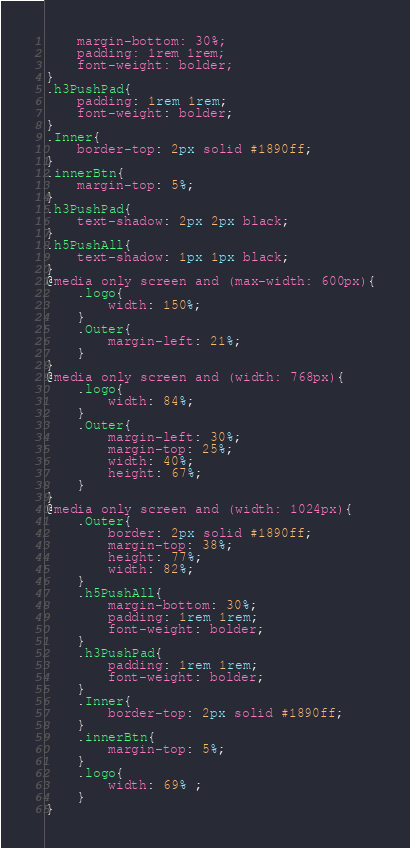Convert code to text. <code><loc_0><loc_0><loc_500><loc_500><_CSS_>    margin-bottom: 30%;
    padding: 1rem 1rem;
    font-weight: bolder;
}
.h3PushPad{
    padding: 1rem 1rem;
    font-weight: bolder;
}
.Inner{
    border-top: 2px solid #1890ff;
}
.innerBtn{
    margin-top: 5%;
}
.h3PushPad{
    text-shadow: 2px 2px black;
}
.h5PushAll{
    text-shadow: 1px 1px black;
}
@media only screen and (max-width: 600px){
    .logo{
        width: 150%;
    }
    .Outer{
        margin-left: 21%;
    }
}
@media only screen and (width: 768px){
    .logo{
        width: 84%;
    }
    .Outer{
        margin-left: 30%;
        margin-top: 25%;
        width: 40%;
        height: 67%;
    }
}
@media only screen and (width: 1024px){
    .Outer{
        border: 2px solid #1890ff;
        margin-top: 38%;
        height: 77%;
        width: 82%;
    }
    .h5PushAll{
        margin-bottom: 30%;
        padding: 1rem 1rem;
        font-weight: bolder;
    }
    .h3PushPad{
        padding: 1rem 1rem;
        font-weight: bolder;
    }
    .Inner{
        border-top: 2px solid #1890ff;
    }
    .innerBtn{
        margin-top: 5%;
    }
    .logo{
        width: 69% ;
    }
}</code> 